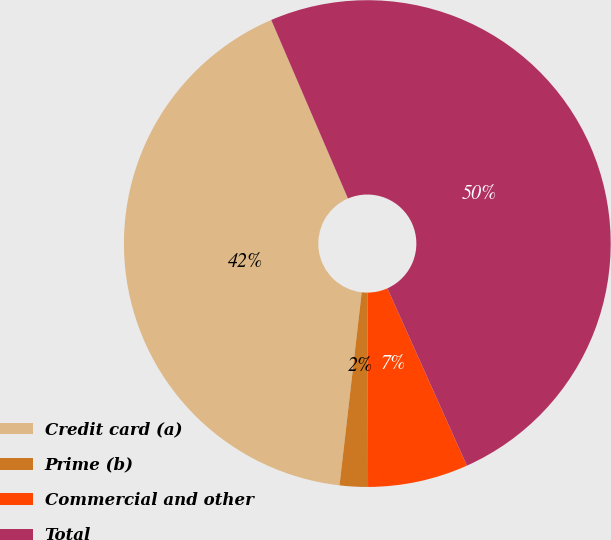<chart> <loc_0><loc_0><loc_500><loc_500><pie_chart><fcel>Credit card (a)<fcel>Prime (b)<fcel>Commercial and other<fcel>Total<nl><fcel>41.72%<fcel>1.87%<fcel>6.66%<fcel>49.75%<nl></chart> 